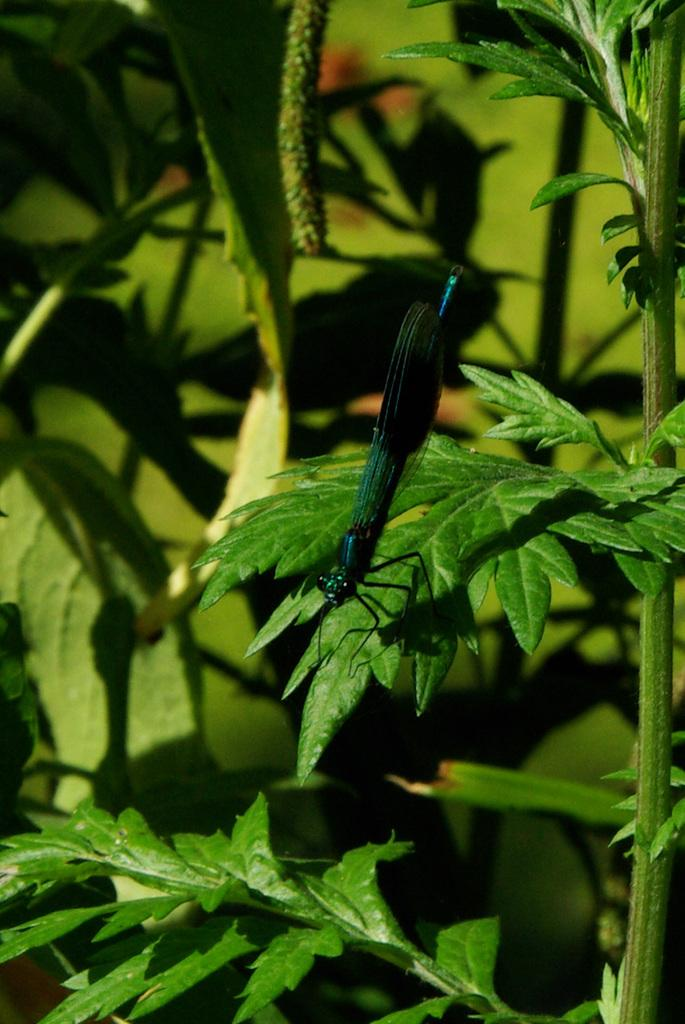What is the main subject of the image? There is a grasshopper in the image. Where is the grasshopper located? The grasshopper is on a leaf. What is the leaf from? The leaf is from a plant. What can be seen in the background of the image? There are other plants visible in the background of the image. What type of floor can be seen in the image? There is no floor visible in the image; it features a grasshopper on a leaf from a plant. How many hands are holding the grasshopper in the image? There are no hands present in the image; it features a grasshopper on a leaf from a plant. 